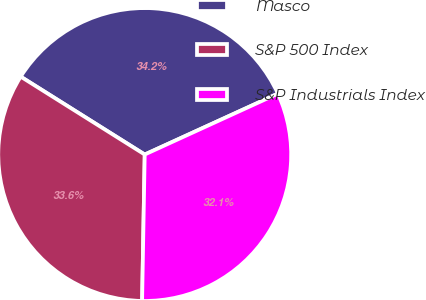<chart> <loc_0><loc_0><loc_500><loc_500><pie_chart><fcel>Masco<fcel>S&P 500 Index<fcel>S&P Industrials Index<nl><fcel>34.25%<fcel>33.64%<fcel>32.11%<nl></chart> 